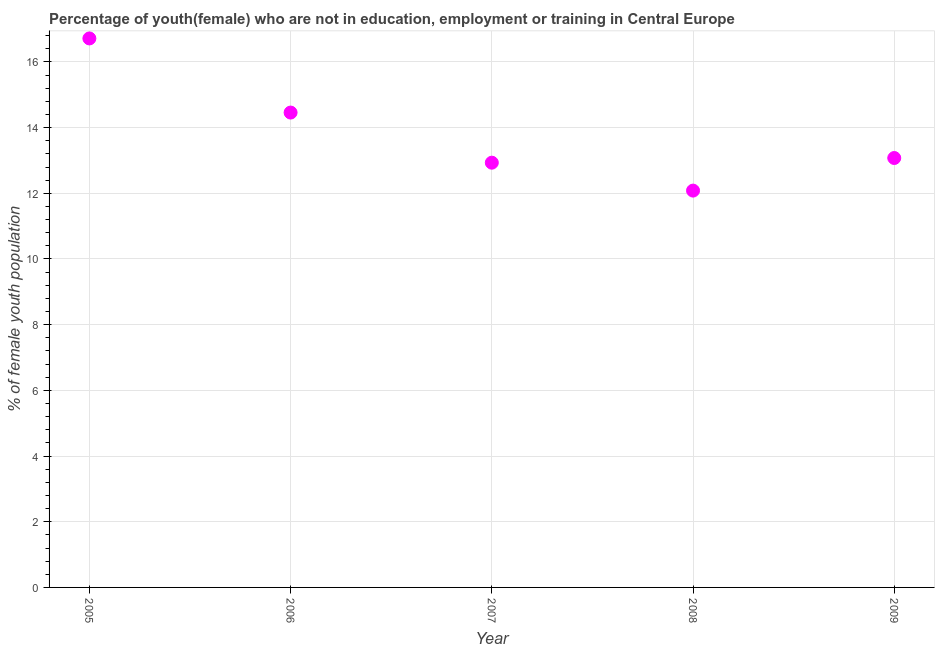What is the unemployed female youth population in 2006?
Your answer should be compact. 14.46. Across all years, what is the maximum unemployed female youth population?
Provide a succinct answer. 16.72. Across all years, what is the minimum unemployed female youth population?
Your answer should be compact. 12.08. In which year was the unemployed female youth population maximum?
Keep it short and to the point. 2005. In which year was the unemployed female youth population minimum?
Ensure brevity in your answer.  2008. What is the sum of the unemployed female youth population?
Provide a short and direct response. 69.26. What is the difference between the unemployed female youth population in 2006 and 2008?
Make the answer very short. 2.38. What is the average unemployed female youth population per year?
Provide a succinct answer. 13.85. What is the median unemployed female youth population?
Your response must be concise. 13.07. In how many years, is the unemployed female youth population greater than 1.2000000000000002 %?
Make the answer very short. 5. Do a majority of the years between 2009 and 2006 (inclusive) have unemployed female youth population greater than 11.6 %?
Give a very brief answer. Yes. What is the ratio of the unemployed female youth population in 2005 to that in 2006?
Offer a very short reply. 1.16. Is the unemployed female youth population in 2005 less than that in 2009?
Offer a terse response. No. What is the difference between the highest and the second highest unemployed female youth population?
Give a very brief answer. 2.26. What is the difference between the highest and the lowest unemployed female youth population?
Provide a succinct answer. 4.63. Does the unemployed female youth population monotonically increase over the years?
Your answer should be compact. No. How many dotlines are there?
Your answer should be compact. 1. What is the title of the graph?
Your response must be concise. Percentage of youth(female) who are not in education, employment or training in Central Europe. What is the label or title of the X-axis?
Keep it short and to the point. Year. What is the label or title of the Y-axis?
Ensure brevity in your answer.  % of female youth population. What is the % of female youth population in 2005?
Offer a terse response. 16.72. What is the % of female youth population in 2006?
Offer a terse response. 14.46. What is the % of female youth population in 2007?
Keep it short and to the point. 12.93. What is the % of female youth population in 2008?
Keep it short and to the point. 12.08. What is the % of female youth population in 2009?
Your answer should be very brief. 13.07. What is the difference between the % of female youth population in 2005 and 2006?
Provide a short and direct response. 2.26. What is the difference between the % of female youth population in 2005 and 2007?
Offer a very short reply. 3.78. What is the difference between the % of female youth population in 2005 and 2008?
Provide a succinct answer. 4.63. What is the difference between the % of female youth population in 2005 and 2009?
Keep it short and to the point. 3.64. What is the difference between the % of female youth population in 2006 and 2007?
Make the answer very short. 1.53. What is the difference between the % of female youth population in 2006 and 2008?
Make the answer very short. 2.38. What is the difference between the % of female youth population in 2006 and 2009?
Keep it short and to the point. 1.38. What is the difference between the % of female youth population in 2007 and 2008?
Ensure brevity in your answer.  0.85. What is the difference between the % of female youth population in 2007 and 2009?
Make the answer very short. -0.14. What is the difference between the % of female youth population in 2008 and 2009?
Provide a short and direct response. -0.99. What is the ratio of the % of female youth population in 2005 to that in 2006?
Provide a succinct answer. 1.16. What is the ratio of the % of female youth population in 2005 to that in 2007?
Offer a terse response. 1.29. What is the ratio of the % of female youth population in 2005 to that in 2008?
Give a very brief answer. 1.38. What is the ratio of the % of female youth population in 2005 to that in 2009?
Your response must be concise. 1.28. What is the ratio of the % of female youth population in 2006 to that in 2007?
Offer a terse response. 1.12. What is the ratio of the % of female youth population in 2006 to that in 2008?
Give a very brief answer. 1.2. What is the ratio of the % of female youth population in 2006 to that in 2009?
Give a very brief answer. 1.11. What is the ratio of the % of female youth population in 2007 to that in 2008?
Make the answer very short. 1.07. What is the ratio of the % of female youth population in 2008 to that in 2009?
Give a very brief answer. 0.92. 